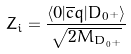Convert formula to latex. <formula><loc_0><loc_0><loc_500><loc_500>Z _ { i } = \frac { \langle 0 | \overline { c } q | D _ { 0 ^ { + } } \rangle } { \sqrt { 2 M _ { D _ { 0 ^ { + } } } } }</formula> 